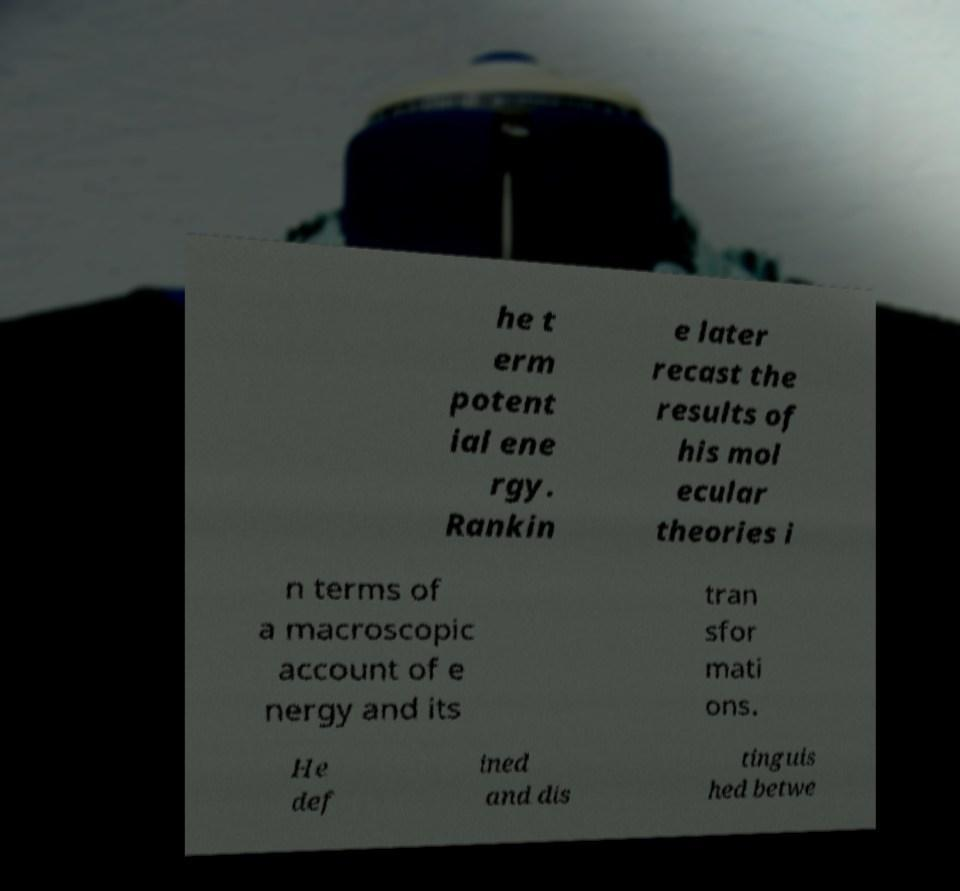Could you assist in decoding the text presented in this image and type it out clearly? he t erm potent ial ene rgy. Rankin e later recast the results of his mol ecular theories i n terms of a macroscopic account of e nergy and its tran sfor mati ons. He def ined and dis tinguis hed betwe 